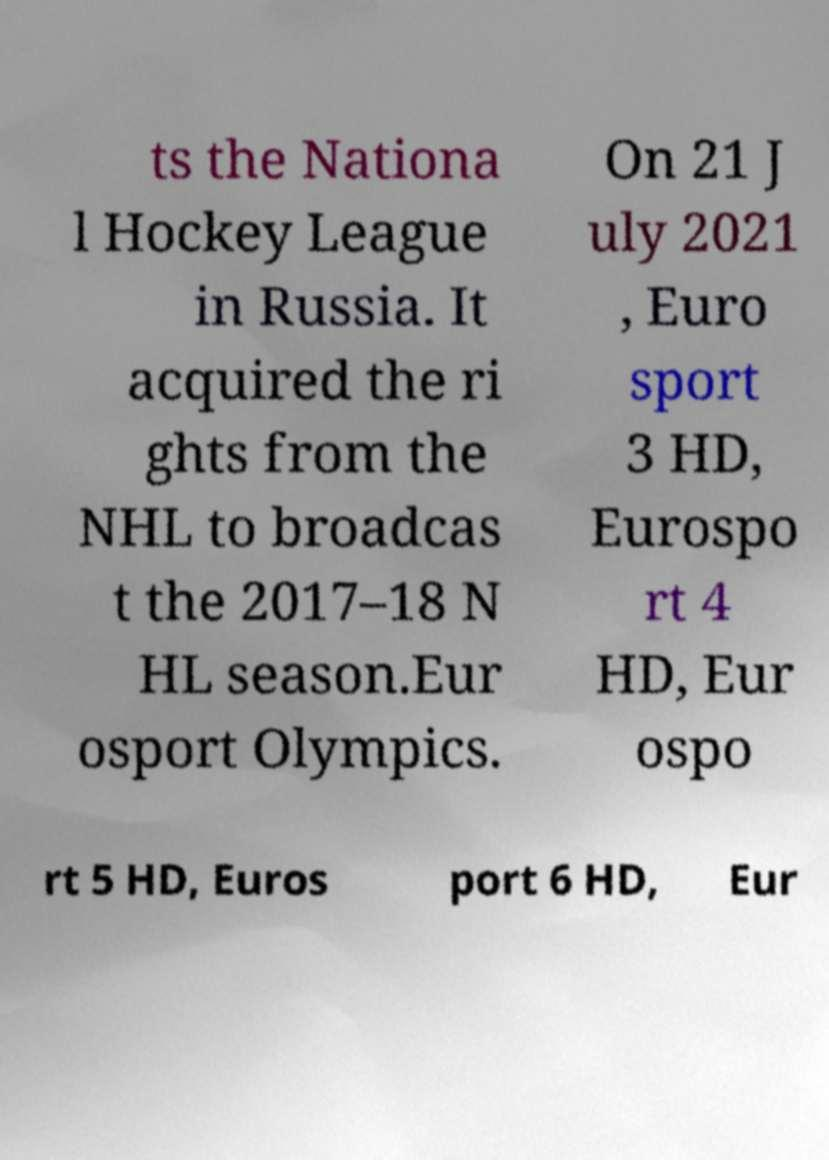Can you accurately transcribe the text from the provided image for me? ts the Nationa l Hockey League in Russia. It acquired the ri ghts from the NHL to broadcas t the 2017–18 N HL season.Eur osport Olympics. On 21 J uly 2021 , Euro sport 3 HD, Eurospo rt 4 HD, Eur ospo rt 5 HD, Euros port 6 HD, Eur 